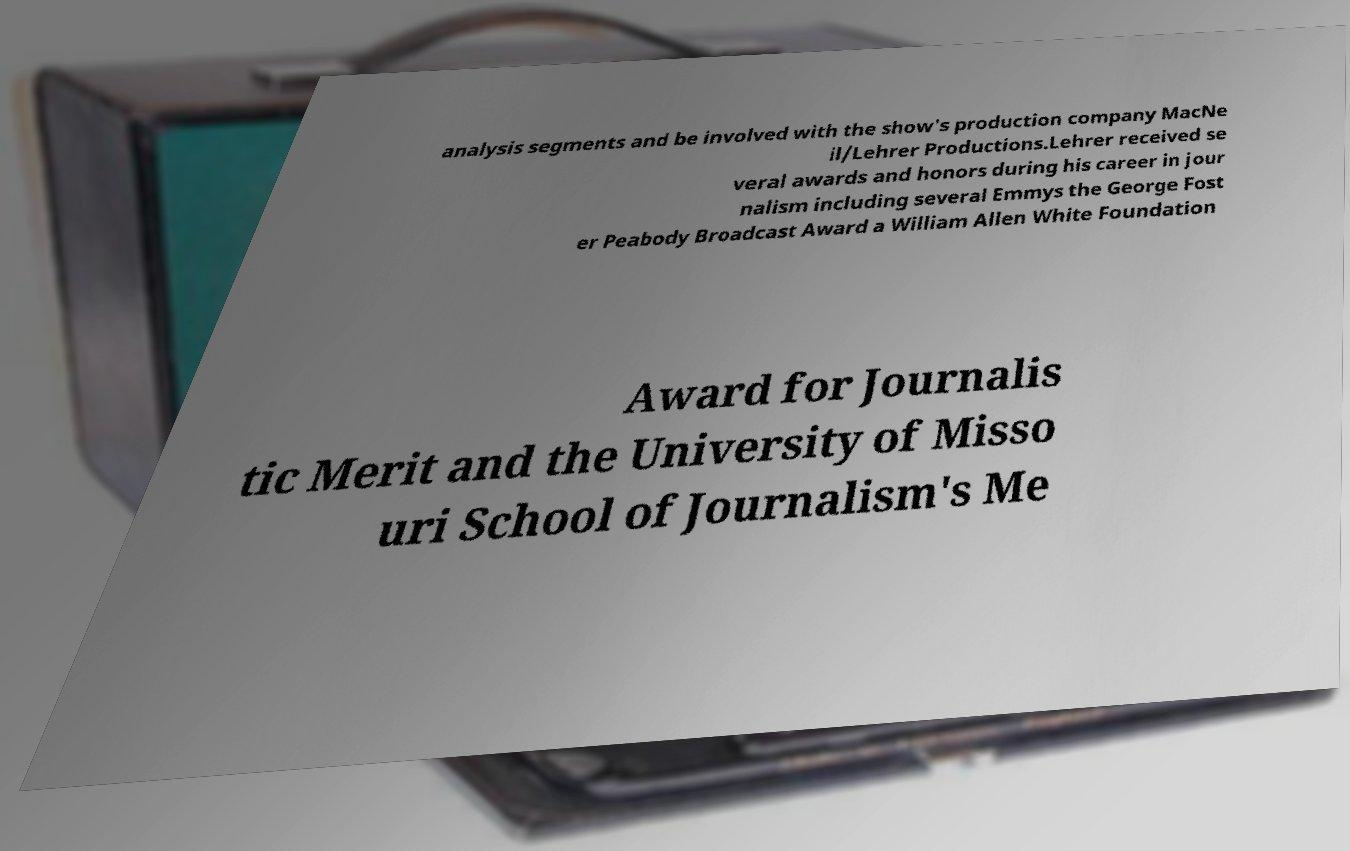Can you read and provide the text displayed in the image?This photo seems to have some interesting text. Can you extract and type it out for me? analysis segments and be involved with the show's production company MacNe il/Lehrer Productions.Lehrer received se veral awards and honors during his career in jour nalism including several Emmys the George Fost er Peabody Broadcast Award a William Allen White Foundation Award for Journalis tic Merit and the University of Misso uri School of Journalism's Me 